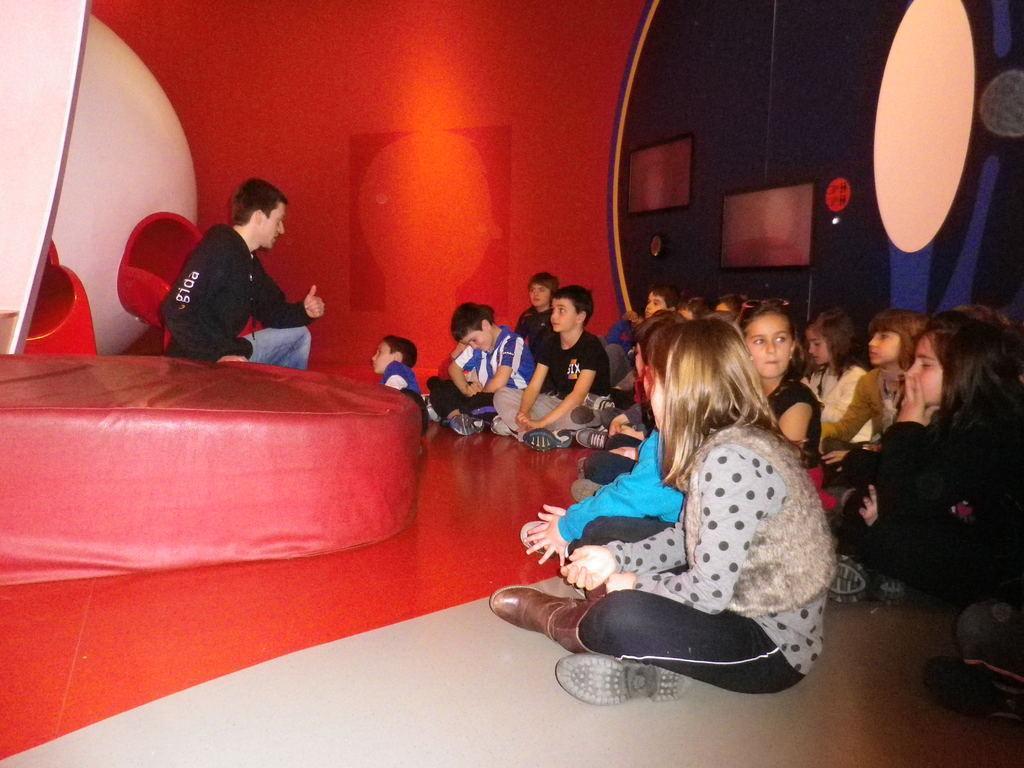Can you describe this image briefly? There are group of people sitting on the floor. This looks like a couch. Here is the man sitting. I think these are the chairs, which are red in color. This looks like a wall with the design on it. I think these are the frames, which are attached to the wall. 